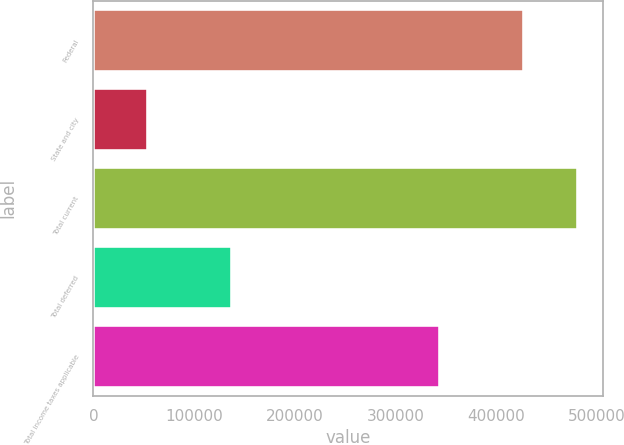Convert chart. <chart><loc_0><loc_0><loc_500><loc_500><bar_chart><fcel>Federal<fcel>State and city<fcel>Total current<fcel>Total deferred<fcel>Total income taxes applicable<nl><fcel>427568<fcel>54030<fcel>481598<fcel>137596<fcel>344002<nl></chart> 